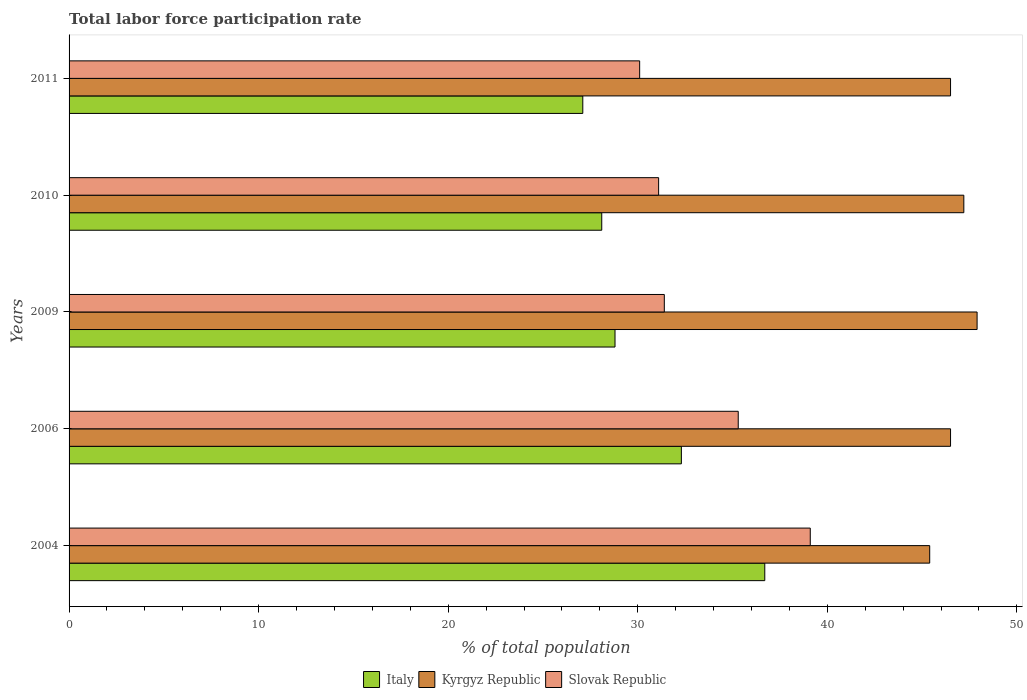How many different coloured bars are there?
Ensure brevity in your answer.  3. How many groups of bars are there?
Provide a short and direct response. 5. Are the number of bars per tick equal to the number of legend labels?
Give a very brief answer. Yes. How many bars are there on the 4th tick from the top?
Make the answer very short. 3. How many bars are there on the 2nd tick from the bottom?
Give a very brief answer. 3. What is the total labor force participation rate in Slovak Republic in 2006?
Your answer should be compact. 35.3. Across all years, what is the maximum total labor force participation rate in Kyrgyz Republic?
Offer a very short reply. 47.9. Across all years, what is the minimum total labor force participation rate in Kyrgyz Republic?
Offer a very short reply. 45.4. What is the total total labor force participation rate in Kyrgyz Republic in the graph?
Ensure brevity in your answer.  233.5. What is the difference between the total labor force participation rate in Slovak Republic in 2006 and that in 2010?
Give a very brief answer. 4.2. What is the difference between the total labor force participation rate in Kyrgyz Republic in 2010 and the total labor force participation rate in Slovak Republic in 2011?
Offer a terse response. 17.1. What is the average total labor force participation rate in Italy per year?
Offer a terse response. 30.6. In the year 2010, what is the difference between the total labor force participation rate in Kyrgyz Republic and total labor force participation rate in Slovak Republic?
Keep it short and to the point. 16.1. What is the ratio of the total labor force participation rate in Italy in 2009 to that in 2011?
Offer a very short reply. 1.06. Is the total labor force participation rate in Italy in 2009 less than that in 2010?
Your response must be concise. No. Is the difference between the total labor force participation rate in Kyrgyz Republic in 2009 and 2011 greater than the difference between the total labor force participation rate in Slovak Republic in 2009 and 2011?
Your response must be concise. Yes. What is the difference between the highest and the second highest total labor force participation rate in Kyrgyz Republic?
Give a very brief answer. 0.7. What is the difference between the highest and the lowest total labor force participation rate in Slovak Republic?
Provide a succinct answer. 9. In how many years, is the total labor force participation rate in Slovak Republic greater than the average total labor force participation rate in Slovak Republic taken over all years?
Your answer should be very brief. 2. Is the sum of the total labor force participation rate in Slovak Republic in 2006 and 2009 greater than the maximum total labor force participation rate in Kyrgyz Republic across all years?
Provide a short and direct response. Yes. What does the 3rd bar from the bottom in 2010 represents?
Keep it short and to the point. Slovak Republic. How many bars are there?
Offer a very short reply. 15. How many years are there in the graph?
Offer a very short reply. 5. What is the difference between two consecutive major ticks on the X-axis?
Your response must be concise. 10. Does the graph contain grids?
Offer a terse response. No. Where does the legend appear in the graph?
Offer a very short reply. Bottom center. How are the legend labels stacked?
Offer a terse response. Horizontal. What is the title of the graph?
Your answer should be very brief. Total labor force participation rate. Does "Vanuatu" appear as one of the legend labels in the graph?
Make the answer very short. No. What is the label or title of the X-axis?
Your response must be concise. % of total population. What is the label or title of the Y-axis?
Offer a very short reply. Years. What is the % of total population in Italy in 2004?
Offer a very short reply. 36.7. What is the % of total population in Kyrgyz Republic in 2004?
Your response must be concise. 45.4. What is the % of total population of Slovak Republic in 2004?
Your answer should be compact. 39.1. What is the % of total population in Italy in 2006?
Your response must be concise. 32.3. What is the % of total population of Kyrgyz Republic in 2006?
Your answer should be very brief. 46.5. What is the % of total population of Slovak Republic in 2006?
Offer a terse response. 35.3. What is the % of total population in Italy in 2009?
Offer a very short reply. 28.8. What is the % of total population in Kyrgyz Republic in 2009?
Provide a succinct answer. 47.9. What is the % of total population of Slovak Republic in 2009?
Your answer should be compact. 31.4. What is the % of total population of Italy in 2010?
Provide a succinct answer. 28.1. What is the % of total population of Kyrgyz Republic in 2010?
Your answer should be compact. 47.2. What is the % of total population of Slovak Republic in 2010?
Give a very brief answer. 31.1. What is the % of total population of Italy in 2011?
Make the answer very short. 27.1. What is the % of total population in Kyrgyz Republic in 2011?
Offer a terse response. 46.5. What is the % of total population in Slovak Republic in 2011?
Keep it short and to the point. 30.1. Across all years, what is the maximum % of total population in Italy?
Keep it short and to the point. 36.7. Across all years, what is the maximum % of total population of Kyrgyz Republic?
Offer a terse response. 47.9. Across all years, what is the maximum % of total population in Slovak Republic?
Provide a short and direct response. 39.1. Across all years, what is the minimum % of total population of Italy?
Your response must be concise. 27.1. Across all years, what is the minimum % of total population in Kyrgyz Republic?
Provide a succinct answer. 45.4. Across all years, what is the minimum % of total population in Slovak Republic?
Offer a very short reply. 30.1. What is the total % of total population in Italy in the graph?
Offer a very short reply. 153. What is the total % of total population in Kyrgyz Republic in the graph?
Offer a terse response. 233.5. What is the total % of total population of Slovak Republic in the graph?
Your answer should be very brief. 167. What is the difference between the % of total population in Italy in 2004 and that in 2006?
Your answer should be very brief. 4.4. What is the difference between the % of total population of Slovak Republic in 2004 and that in 2006?
Give a very brief answer. 3.8. What is the difference between the % of total population in Italy in 2004 and that in 2009?
Provide a short and direct response. 7.9. What is the difference between the % of total population in Kyrgyz Republic in 2004 and that in 2009?
Ensure brevity in your answer.  -2.5. What is the difference between the % of total population of Slovak Republic in 2004 and that in 2009?
Ensure brevity in your answer.  7.7. What is the difference between the % of total population of Italy in 2004 and that in 2010?
Provide a short and direct response. 8.6. What is the difference between the % of total population of Kyrgyz Republic in 2004 and that in 2010?
Make the answer very short. -1.8. What is the difference between the % of total population of Italy in 2004 and that in 2011?
Your answer should be very brief. 9.6. What is the difference between the % of total population in Italy in 2006 and that in 2009?
Your response must be concise. 3.5. What is the difference between the % of total population of Kyrgyz Republic in 2006 and that in 2010?
Your response must be concise. -0.7. What is the difference between the % of total population of Kyrgyz Republic in 2006 and that in 2011?
Give a very brief answer. 0. What is the difference between the % of total population in Italy in 2009 and that in 2010?
Offer a very short reply. 0.7. What is the difference between the % of total population in Kyrgyz Republic in 2009 and that in 2010?
Offer a terse response. 0.7. What is the difference between the % of total population in Kyrgyz Republic in 2009 and that in 2011?
Keep it short and to the point. 1.4. What is the difference between the % of total population of Slovak Republic in 2009 and that in 2011?
Offer a very short reply. 1.3. What is the difference between the % of total population of Italy in 2010 and that in 2011?
Provide a short and direct response. 1. What is the difference between the % of total population of Kyrgyz Republic in 2010 and that in 2011?
Make the answer very short. 0.7. What is the difference between the % of total population in Slovak Republic in 2010 and that in 2011?
Offer a terse response. 1. What is the difference between the % of total population of Kyrgyz Republic in 2004 and the % of total population of Slovak Republic in 2006?
Keep it short and to the point. 10.1. What is the difference between the % of total population in Italy in 2004 and the % of total population in Kyrgyz Republic in 2009?
Give a very brief answer. -11.2. What is the difference between the % of total population of Italy in 2004 and the % of total population of Slovak Republic in 2009?
Your answer should be very brief. 5.3. What is the difference between the % of total population in Italy in 2004 and the % of total population in Kyrgyz Republic in 2010?
Your response must be concise. -10.5. What is the difference between the % of total population in Italy in 2004 and the % of total population in Kyrgyz Republic in 2011?
Offer a terse response. -9.8. What is the difference between the % of total population in Kyrgyz Republic in 2004 and the % of total population in Slovak Republic in 2011?
Offer a very short reply. 15.3. What is the difference between the % of total population in Italy in 2006 and the % of total population in Kyrgyz Republic in 2009?
Keep it short and to the point. -15.6. What is the difference between the % of total population in Italy in 2006 and the % of total population in Kyrgyz Republic in 2010?
Provide a short and direct response. -14.9. What is the difference between the % of total population of Italy in 2006 and the % of total population of Slovak Republic in 2010?
Offer a very short reply. 1.2. What is the difference between the % of total population in Italy in 2006 and the % of total population in Kyrgyz Republic in 2011?
Provide a short and direct response. -14.2. What is the difference between the % of total population in Italy in 2006 and the % of total population in Slovak Republic in 2011?
Your answer should be very brief. 2.2. What is the difference between the % of total population in Kyrgyz Republic in 2006 and the % of total population in Slovak Republic in 2011?
Keep it short and to the point. 16.4. What is the difference between the % of total population in Italy in 2009 and the % of total population in Kyrgyz Republic in 2010?
Provide a short and direct response. -18.4. What is the difference between the % of total population in Italy in 2009 and the % of total population in Slovak Republic in 2010?
Your response must be concise. -2.3. What is the difference between the % of total population of Kyrgyz Republic in 2009 and the % of total population of Slovak Republic in 2010?
Offer a terse response. 16.8. What is the difference between the % of total population in Italy in 2009 and the % of total population in Kyrgyz Republic in 2011?
Your answer should be compact. -17.7. What is the difference between the % of total population in Italy in 2009 and the % of total population in Slovak Republic in 2011?
Offer a very short reply. -1.3. What is the difference between the % of total population in Italy in 2010 and the % of total population in Kyrgyz Republic in 2011?
Offer a very short reply. -18.4. What is the difference between the % of total population of Italy in 2010 and the % of total population of Slovak Republic in 2011?
Provide a short and direct response. -2. What is the difference between the % of total population of Kyrgyz Republic in 2010 and the % of total population of Slovak Republic in 2011?
Offer a terse response. 17.1. What is the average % of total population in Italy per year?
Give a very brief answer. 30.6. What is the average % of total population in Kyrgyz Republic per year?
Offer a terse response. 46.7. What is the average % of total population in Slovak Republic per year?
Your answer should be very brief. 33.4. In the year 2004, what is the difference between the % of total population in Italy and % of total population in Slovak Republic?
Provide a short and direct response. -2.4. In the year 2006, what is the difference between the % of total population of Italy and % of total population of Kyrgyz Republic?
Ensure brevity in your answer.  -14.2. In the year 2009, what is the difference between the % of total population of Italy and % of total population of Kyrgyz Republic?
Give a very brief answer. -19.1. In the year 2010, what is the difference between the % of total population of Italy and % of total population of Kyrgyz Republic?
Make the answer very short. -19.1. In the year 2010, what is the difference between the % of total population in Italy and % of total population in Slovak Republic?
Ensure brevity in your answer.  -3. In the year 2010, what is the difference between the % of total population of Kyrgyz Republic and % of total population of Slovak Republic?
Keep it short and to the point. 16.1. In the year 2011, what is the difference between the % of total population in Italy and % of total population in Kyrgyz Republic?
Offer a very short reply. -19.4. In the year 2011, what is the difference between the % of total population of Italy and % of total population of Slovak Republic?
Offer a terse response. -3. In the year 2011, what is the difference between the % of total population of Kyrgyz Republic and % of total population of Slovak Republic?
Your answer should be very brief. 16.4. What is the ratio of the % of total population of Italy in 2004 to that in 2006?
Provide a short and direct response. 1.14. What is the ratio of the % of total population of Kyrgyz Republic in 2004 to that in 2006?
Your answer should be compact. 0.98. What is the ratio of the % of total population in Slovak Republic in 2004 to that in 2006?
Provide a succinct answer. 1.11. What is the ratio of the % of total population of Italy in 2004 to that in 2009?
Provide a short and direct response. 1.27. What is the ratio of the % of total population of Kyrgyz Republic in 2004 to that in 2009?
Provide a short and direct response. 0.95. What is the ratio of the % of total population of Slovak Republic in 2004 to that in 2009?
Your response must be concise. 1.25. What is the ratio of the % of total population in Italy in 2004 to that in 2010?
Provide a short and direct response. 1.31. What is the ratio of the % of total population in Kyrgyz Republic in 2004 to that in 2010?
Your answer should be compact. 0.96. What is the ratio of the % of total population in Slovak Republic in 2004 to that in 2010?
Offer a terse response. 1.26. What is the ratio of the % of total population of Italy in 2004 to that in 2011?
Your answer should be compact. 1.35. What is the ratio of the % of total population in Kyrgyz Republic in 2004 to that in 2011?
Give a very brief answer. 0.98. What is the ratio of the % of total population of Slovak Republic in 2004 to that in 2011?
Give a very brief answer. 1.3. What is the ratio of the % of total population of Italy in 2006 to that in 2009?
Your response must be concise. 1.12. What is the ratio of the % of total population of Kyrgyz Republic in 2006 to that in 2009?
Provide a short and direct response. 0.97. What is the ratio of the % of total population in Slovak Republic in 2006 to that in 2009?
Provide a short and direct response. 1.12. What is the ratio of the % of total population in Italy in 2006 to that in 2010?
Provide a short and direct response. 1.15. What is the ratio of the % of total population in Kyrgyz Republic in 2006 to that in 2010?
Provide a succinct answer. 0.99. What is the ratio of the % of total population in Slovak Republic in 2006 to that in 2010?
Your response must be concise. 1.14. What is the ratio of the % of total population in Italy in 2006 to that in 2011?
Offer a very short reply. 1.19. What is the ratio of the % of total population in Slovak Republic in 2006 to that in 2011?
Ensure brevity in your answer.  1.17. What is the ratio of the % of total population of Italy in 2009 to that in 2010?
Your answer should be compact. 1.02. What is the ratio of the % of total population of Kyrgyz Republic in 2009 to that in 2010?
Your response must be concise. 1.01. What is the ratio of the % of total population in Slovak Republic in 2009 to that in 2010?
Offer a very short reply. 1.01. What is the ratio of the % of total population in Italy in 2009 to that in 2011?
Give a very brief answer. 1.06. What is the ratio of the % of total population of Kyrgyz Republic in 2009 to that in 2011?
Make the answer very short. 1.03. What is the ratio of the % of total population of Slovak Republic in 2009 to that in 2011?
Give a very brief answer. 1.04. What is the ratio of the % of total population in Italy in 2010 to that in 2011?
Provide a succinct answer. 1.04. What is the ratio of the % of total population in Kyrgyz Republic in 2010 to that in 2011?
Provide a short and direct response. 1.02. What is the ratio of the % of total population of Slovak Republic in 2010 to that in 2011?
Your answer should be compact. 1.03. What is the difference between the highest and the second highest % of total population of Italy?
Offer a very short reply. 4.4. What is the difference between the highest and the lowest % of total population of Italy?
Your answer should be very brief. 9.6. What is the difference between the highest and the lowest % of total population of Slovak Republic?
Your answer should be compact. 9. 